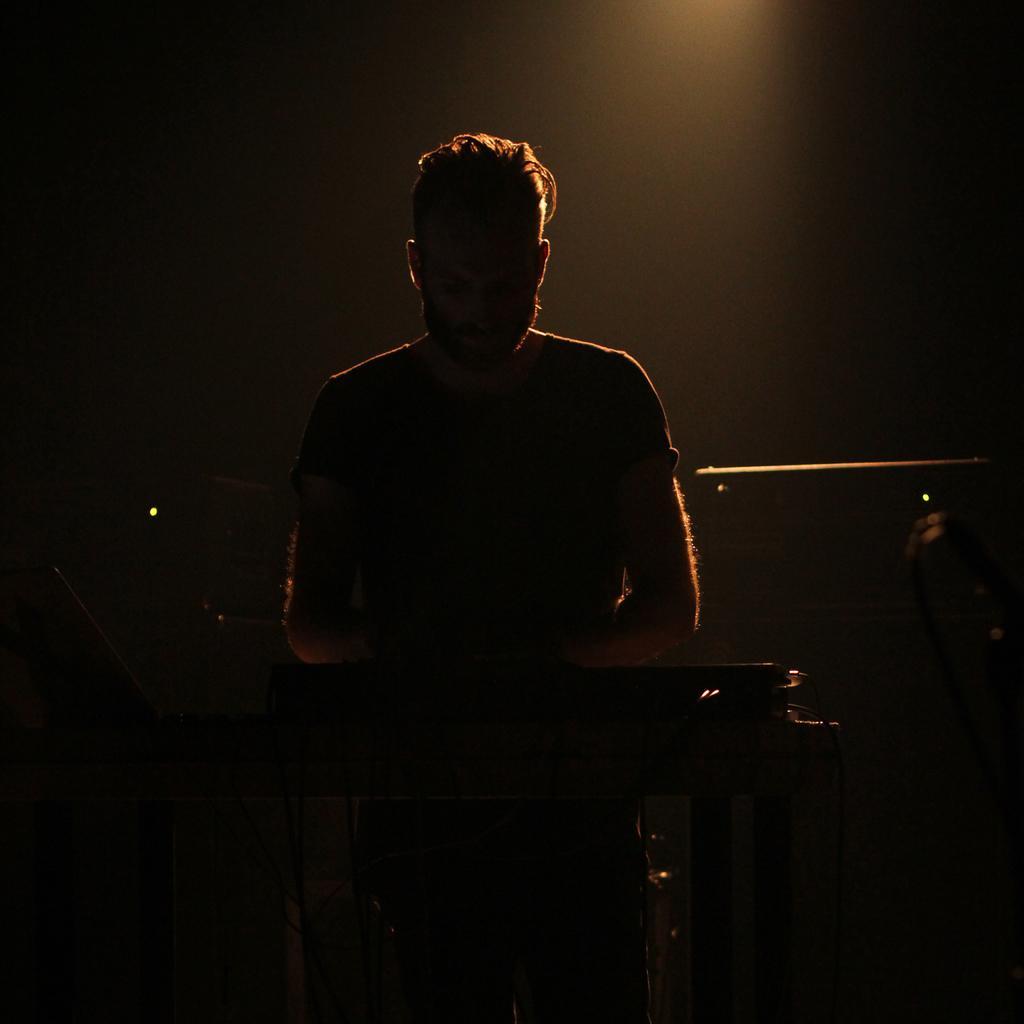Could you give a brief overview of what you see in this image? In the image we can see a man standing and wearing clothes. In front of him there is a musical instrument and this is a cable wire. 